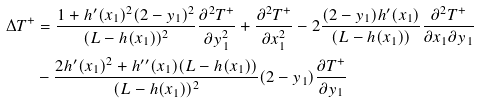<formula> <loc_0><loc_0><loc_500><loc_500>\Delta T ^ { + } & = \frac { 1 + h ^ { \prime } ( x _ { 1 } ) ^ { 2 } ( 2 - y _ { 1 } ) ^ { 2 } } { ( L - h ( x _ { 1 } ) ) ^ { 2 } } \frac { \partial ^ { 2 } T ^ { + } } { \partial y _ { 1 } ^ { 2 } } + \frac { \partial ^ { 2 } T ^ { + } } { \partial x _ { 1 } ^ { 2 } } - 2 \frac { ( 2 - y _ { 1 } ) h ^ { \prime } ( x _ { 1 } ) } { ( L - h ( x _ { 1 } ) ) } \frac { \partial ^ { 2 } T ^ { + } } { \partial x _ { 1 } \partial y _ { 1 } } \\ & - \frac { 2 h ^ { \prime } ( x _ { 1 } ) ^ { 2 } + h ^ { \prime \prime } ( x _ { 1 } ) ( L - h ( x _ { 1 } ) ) } { ( L - h ( x _ { 1 } ) ) ^ { 2 } } ( 2 - y _ { 1 } ) \frac { \partial T ^ { + } } { \partial y _ { 1 } }</formula> 